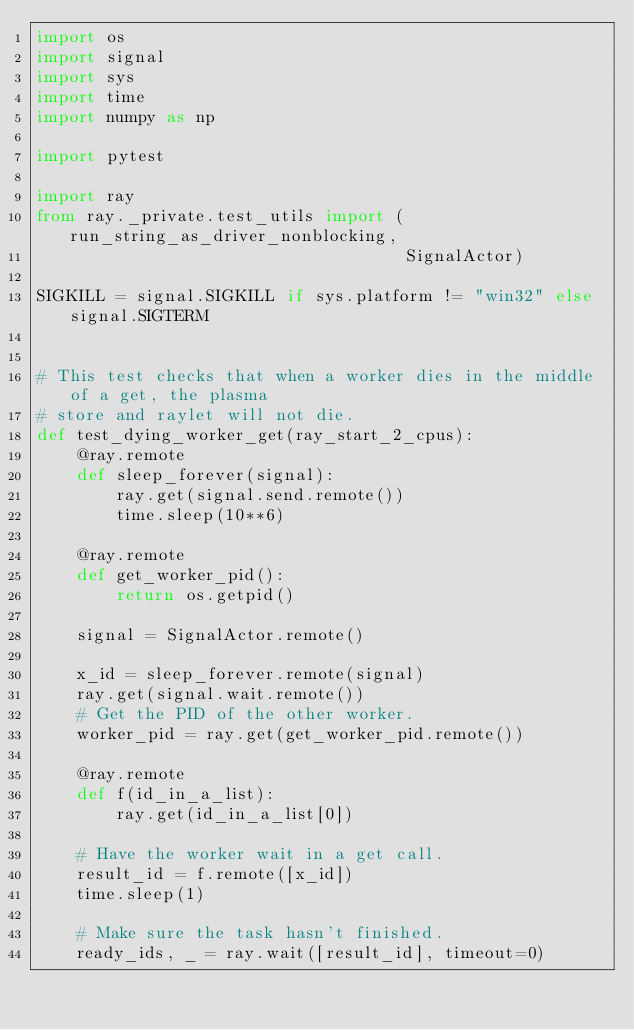Convert code to text. <code><loc_0><loc_0><loc_500><loc_500><_Python_>import os
import signal
import sys
import time
import numpy as np

import pytest

import ray
from ray._private.test_utils import (run_string_as_driver_nonblocking,
                                     SignalActor)

SIGKILL = signal.SIGKILL if sys.platform != "win32" else signal.SIGTERM


# This test checks that when a worker dies in the middle of a get, the plasma
# store and raylet will not die.
def test_dying_worker_get(ray_start_2_cpus):
    @ray.remote
    def sleep_forever(signal):
        ray.get(signal.send.remote())
        time.sleep(10**6)

    @ray.remote
    def get_worker_pid():
        return os.getpid()

    signal = SignalActor.remote()

    x_id = sleep_forever.remote(signal)
    ray.get(signal.wait.remote())
    # Get the PID of the other worker.
    worker_pid = ray.get(get_worker_pid.remote())

    @ray.remote
    def f(id_in_a_list):
        ray.get(id_in_a_list[0])

    # Have the worker wait in a get call.
    result_id = f.remote([x_id])
    time.sleep(1)

    # Make sure the task hasn't finished.
    ready_ids, _ = ray.wait([result_id], timeout=0)</code> 